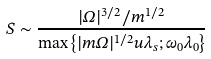<formula> <loc_0><loc_0><loc_500><loc_500>S \sim \frac { | \Omega | ^ { 3 / 2 } / m ^ { 1 / 2 } } { \max \left \{ | m \Omega | ^ { 1 / 2 } u \lambda _ { s } ; \omega _ { 0 } \lambda _ { 0 } \right \} }</formula> 